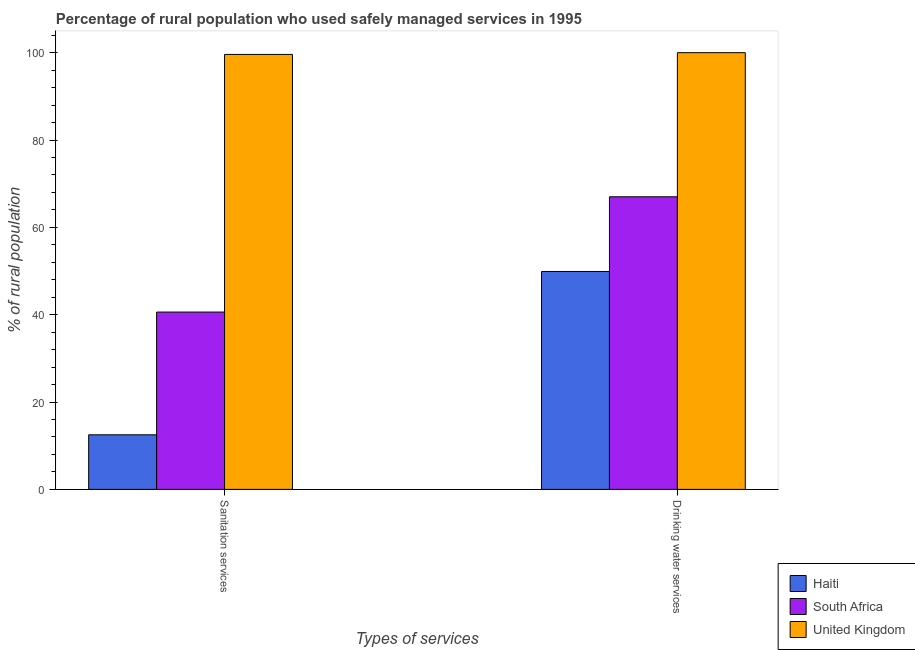How many different coloured bars are there?
Make the answer very short. 3. How many groups of bars are there?
Provide a short and direct response. 2. How many bars are there on the 2nd tick from the left?
Offer a terse response. 3. What is the label of the 2nd group of bars from the left?
Your answer should be very brief. Drinking water services. What is the percentage of rural population who used drinking water services in South Africa?
Offer a very short reply. 67. Across all countries, what is the maximum percentage of rural population who used drinking water services?
Ensure brevity in your answer.  100. Across all countries, what is the minimum percentage of rural population who used drinking water services?
Your response must be concise. 49.9. In which country was the percentage of rural population who used drinking water services maximum?
Your response must be concise. United Kingdom. In which country was the percentage of rural population who used sanitation services minimum?
Ensure brevity in your answer.  Haiti. What is the total percentage of rural population who used sanitation services in the graph?
Provide a succinct answer. 152.7. What is the difference between the percentage of rural population who used sanitation services in South Africa and that in Haiti?
Give a very brief answer. 28.1. What is the difference between the percentage of rural population who used drinking water services in Haiti and the percentage of rural population who used sanitation services in United Kingdom?
Offer a very short reply. -49.7. What is the average percentage of rural population who used drinking water services per country?
Offer a terse response. 72.3. What is the difference between the percentage of rural population who used drinking water services and percentage of rural population who used sanitation services in South Africa?
Your answer should be very brief. 26.4. What is the ratio of the percentage of rural population who used drinking water services in South Africa to that in Haiti?
Your answer should be compact. 1.34. What does the 2nd bar from the left in Drinking water services represents?
Your answer should be very brief. South Africa. What does the 2nd bar from the right in Drinking water services represents?
Your answer should be compact. South Africa. Are all the bars in the graph horizontal?
Provide a short and direct response. No. Where does the legend appear in the graph?
Your answer should be compact. Bottom right. How many legend labels are there?
Ensure brevity in your answer.  3. How are the legend labels stacked?
Provide a succinct answer. Vertical. What is the title of the graph?
Provide a short and direct response. Percentage of rural population who used safely managed services in 1995. What is the label or title of the X-axis?
Your answer should be very brief. Types of services. What is the label or title of the Y-axis?
Provide a short and direct response. % of rural population. What is the % of rural population in South Africa in Sanitation services?
Provide a succinct answer. 40.6. What is the % of rural population of United Kingdom in Sanitation services?
Provide a succinct answer. 99.6. What is the % of rural population in Haiti in Drinking water services?
Your response must be concise. 49.9. What is the % of rural population of South Africa in Drinking water services?
Offer a very short reply. 67. What is the % of rural population in United Kingdom in Drinking water services?
Keep it short and to the point. 100. Across all Types of services, what is the maximum % of rural population of Haiti?
Offer a very short reply. 49.9. Across all Types of services, what is the maximum % of rural population of United Kingdom?
Offer a terse response. 100. Across all Types of services, what is the minimum % of rural population of Haiti?
Ensure brevity in your answer.  12.5. Across all Types of services, what is the minimum % of rural population of South Africa?
Offer a terse response. 40.6. Across all Types of services, what is the minimum % of rural population in United Kingdom?
Provide a short and direct response. 99.6. What is the total % of rural population of Haiti in the graph?
Your answer should be very brief. 62.4. What is the total % of rural population in South Africa in the graph?
Provide a short and direct response. 107.6. What is the total % of rural population in United Kingdom in the graph?
Offer a very short reply. 199.6. What is the difference between the % of rural population in Haiti in Sanitation services and that in Drinking water services?
Offer a very short reply. -37.4. What is the difference between the % of rural population of South Africa in Sanitation services and that in Drinking water services?
Keep it short and to the point. -26.4. What is the difference between the % of rural population in Haiti in Sanitation services and the % of rural population in South Africa in Drinking water services?
Provide a short and direct response. -54.5. What is the difference between the % of rural population of Haiti in Sanitation services and the % of rural population of United Kingdom in Drinking water services?
Make the answer very short. -87.5. What is the difference between the % of rural population in South Africa in Sanitation services and the % of rural population in United Kingdom in Drinking water services?
Provide a short and direct response. -59.4. What is the average % of rural population of Haiti per Types of services?
Your response must be concise. 31.2. What is the average % of rural population in South Africa per Types of services?
Offer a terse response. 53.8. What is the average % of rural population in United Kingdom per Types of services?
Ensure brevity in your answer.  99.8. What is the difference between the % of rural population of Haiti and % of rural population of South Africa in Sanitation services?
Give a very brief answer. -28.1. What is the difference between the % of rural population in Haiti and % of rural population in United Kingdom in Sanitation services?
Provide a short and direct response. -87.1. What is the difference between the % of rural population in South Africa and % of rural population in United Kingdom in Sanitation services?
Offer a terse response. -59. What is the difference between the % of rural population of Haiti and % of rural population of South Africa in Drinking water services?
Make the answer very short. -17.1. What is the difference between the % of rural population in Haiti and % of rural population in United Kingdom in Drinking water services?
Make the answer very short. -50.1. What is the difference between the % of rural population of South Africa and % of rural population of United Kingdom in Drinking water services?
Provide a short and direct response. -33. What is the ratio of the % of rural population of Haiti in Sanitation services to that in Drinking water services?
Ensure brevity in your answer.  0.25. What is the ratio of the % of rural population in South Africa in Sanitation services to that in Drinking water services?
Ensure brevity in your answer.  0.61. What is the ratio of the % of rural population of United Kingdom in Sanitation services to that in Drinking water services?
Ensure brevity in your answer.  1. What is the difference between the highest and the second highest % of rural population of Haiti?
Provide a succinct answer. 37.4. What is the difference between the highest and the second highest % of rural population of South Africa?
Your answer should be compact. 26.4. What is the difference between the highest and the lowest % of rural population of Haiti?
Your answer should be compact. 37.4. What is the difference between the highest and the lowest % of rural population of South Africa?
Keep it short and to the point. 26.4. What is the difference between the highest and the lowest % of rural population of United Kingdom?
Your response must be concise. 0.4. 